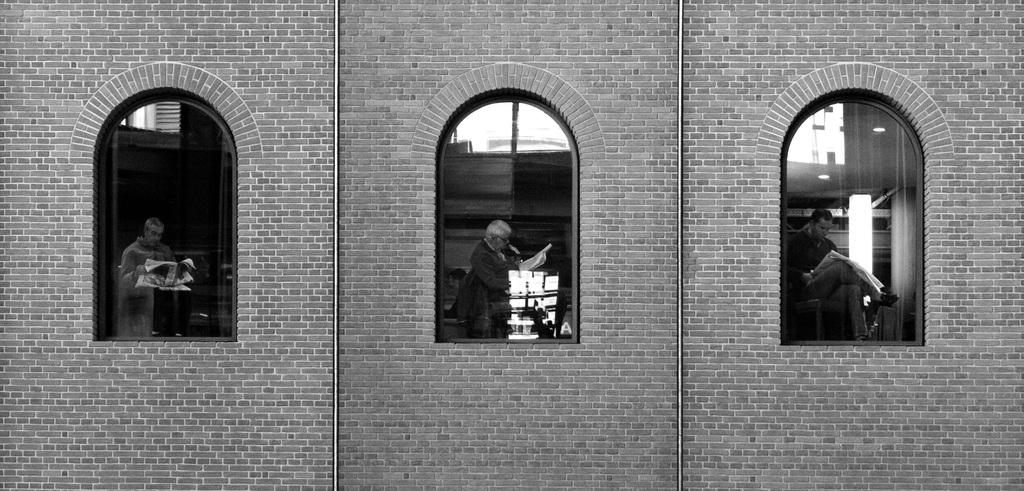What type of structure is visible in the image? There is a brick wall in the image. What feature can be seen on the brick wall? The brick wall has windows. Who or what is present in the image besides the brick wall? There are people in the image. What are the people holding in their hands? The people are holding objects in their hands. What is the color scheme of the image? The image is black and white in color. How many numbers can be seen in the image? There are no numbers visible in the image. 